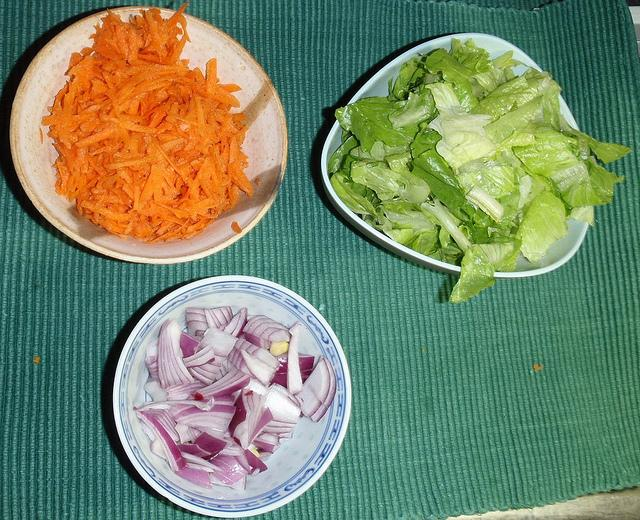What type of food are all of these?

Choices:
A) vegetables
B) protein
C) fruit
D) starch vegetables 